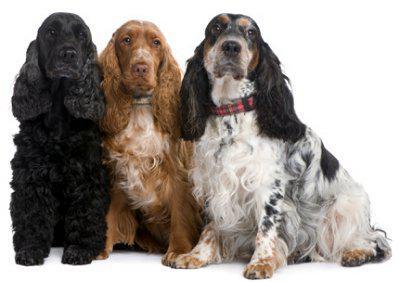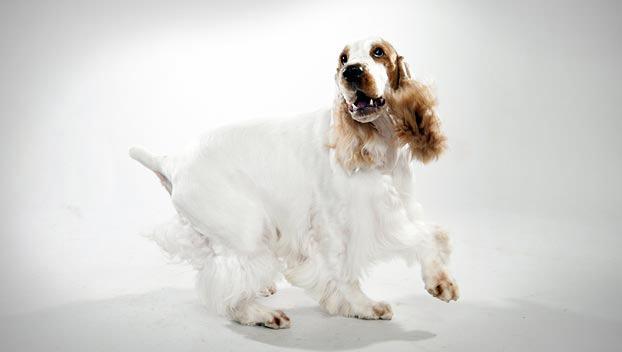The first image is the image on the left, the second image is the image on the right. Examine the images to the left and right. Is the description "The image contains a full bodied white dog, with brown ears, looking left." accurate? Answer yes or no. Yes. The first image is the image on the left, the second image is the image on the right. For the images displayed, is the sentence "There are at most two dogs." factually correct? Answer yes or no. No. 